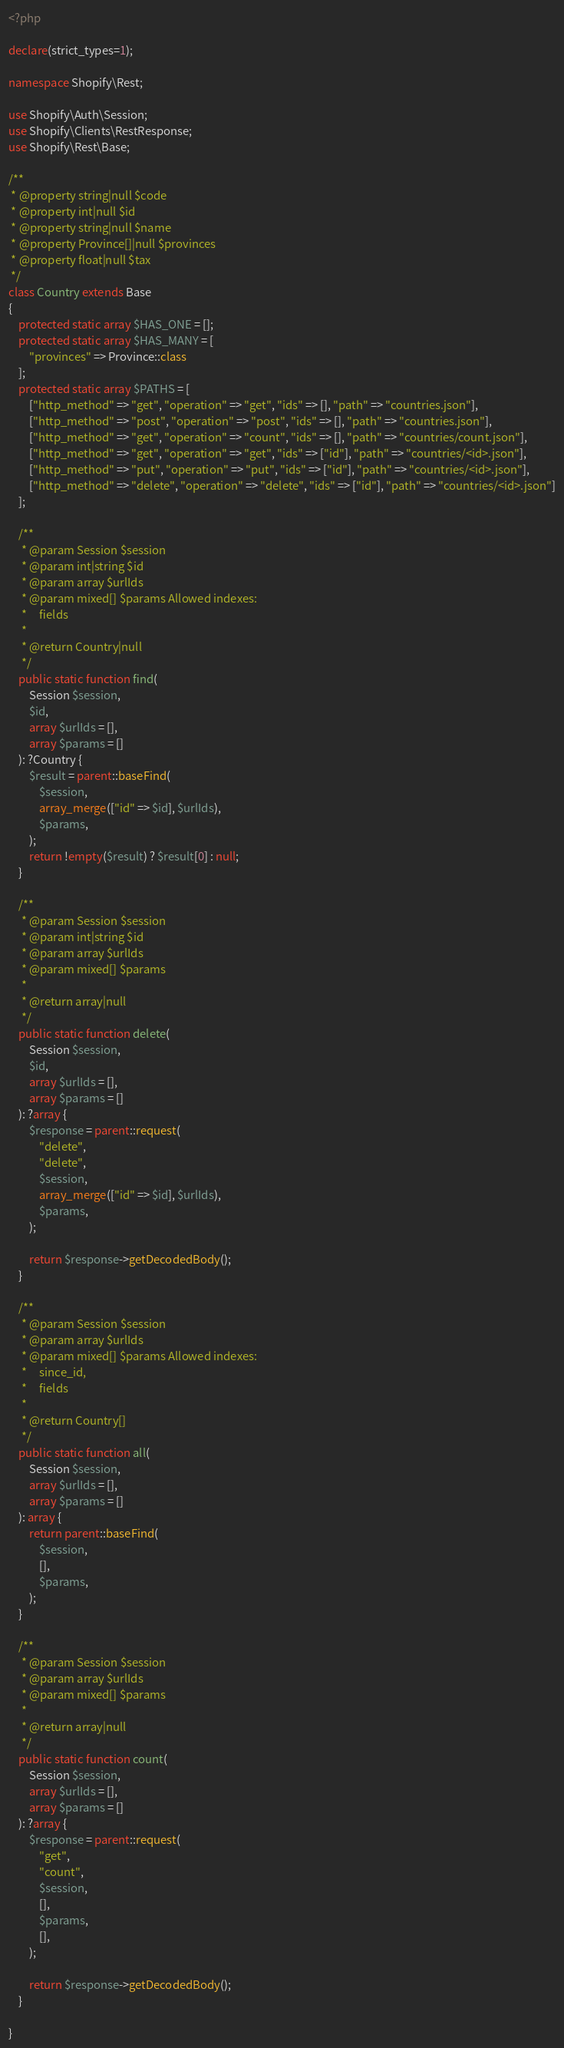<code> <loc_0><loc_0><loc_500><loc_500><_PHP_><?php

declare(strict_types=1);

namespace Shopify\Rest;

use Shopify\Auth\Session;
use Shopify\Clients\RestResponse;
use Shopify\Rest\Base;

/**
 * @property string|null $code
 * @property int|null $id
 * @property string|null $name
 * @property Province[]|null $provinces
 * @property float|null $tax
 */
class Country extends Base
{
    protected static array $HAS_ONE = [];
    protected static array $HAS_MANY = [
        "provinces" => Province::class
    ];
    protected static array $PATHS = [
        ["http_method" => "get", "operation" => "get", "ids" => [], "path" => "countries.json"],
        ["http_method" => "post", "operation" => "post", "ids" => [], "path" => "countries.json"],
        ["http_method" => "get", "operation" => "count", "ids" => [], "path" => "countries/count.json"],
        ["http_method" => "get", "operation" => "get", "ids" => ["id"], "path" => "countries/<id>.json"],
        ["http_method" => "put", "operation" => "put", "ids" => ["id"], "path" => "countries/<id>.json"],
        ["http_method" => "delete", "operation" => "delete", "ids" => ["id"], "path" => "countries/<id>.json"]
    ];

    /**
     * @param Session $session
     * @param int|string $id
     * @param array $urlIds
     * @param mixed[] $params Allowed indexes:
     *     fields
     *
     * @return Country|null
     */
    public static function find(
        Session $session,
        $id,
        array $urlIds = [],
        array $params = []
    ): ?Country {
        $result = parent::baseFind(
            $session,
            array_merge(["id" => $id], $urlIds),
            $params,
        );
        return !empty($result) ? $result[0] : null;
    }

    /**
     * @param Session $session
     * @param int|string $id
     * @param array $urlIds
     * @param mixed[] $params
     *
     * @return array|null
     */
    public static function delete(
        Session $session,
        $id,
        array $urlIds = [],
        array $params = []
    ): ?array {
        $response = parent::request(
            "delete",
            "delete",
            $session,
            array_merge(["id" => $id], $urlIds),
            $params,
        );

        return $response->getDecodedBody();
    }

    /**
     * @param Session $session
     * @param array $urlIds
     * @param mixed[] $params Allowed indexes:
     *     since_id,
     *     fields
     *
     * @return Country[]
     */
    public static function all(
        Session $session,
        array $urlIds = [],
        array $params = []
    ): array {
        return parent::baseFind(
            $session,
            [],
            $params,
        );
    }

    /**
     * @param Session $session
     * @param array $urlIds
     * @param mixed[] $params
     *
     * @return array|null
     */
    public static function count(
        Session $session,
        array $urlIds = [],
        array $params = []
    ): ?array {
        $response = parent::request(
            "get",
            "count",
            $session,
            [],
            $params,
            [],
        );

        return $response->getDecodedBody();
    }

}
</code> 